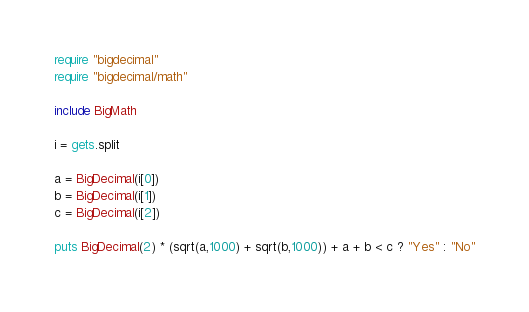<code> <loc_0><loc_0><loc_500><loc_500><_Ruby_>require "bigdecimal"
require "bigdecimal/math"

include BigMath

i = gets.split

a = BigDecimal(i[0])
b = BigDecimal(i[1])
c = BigDecimal(i[2])

puts BigDecimal(2) * (sqrt(a,1000) + sqrt(b,1000)) + a + b < c ? "Yes" : "No"
</code> 